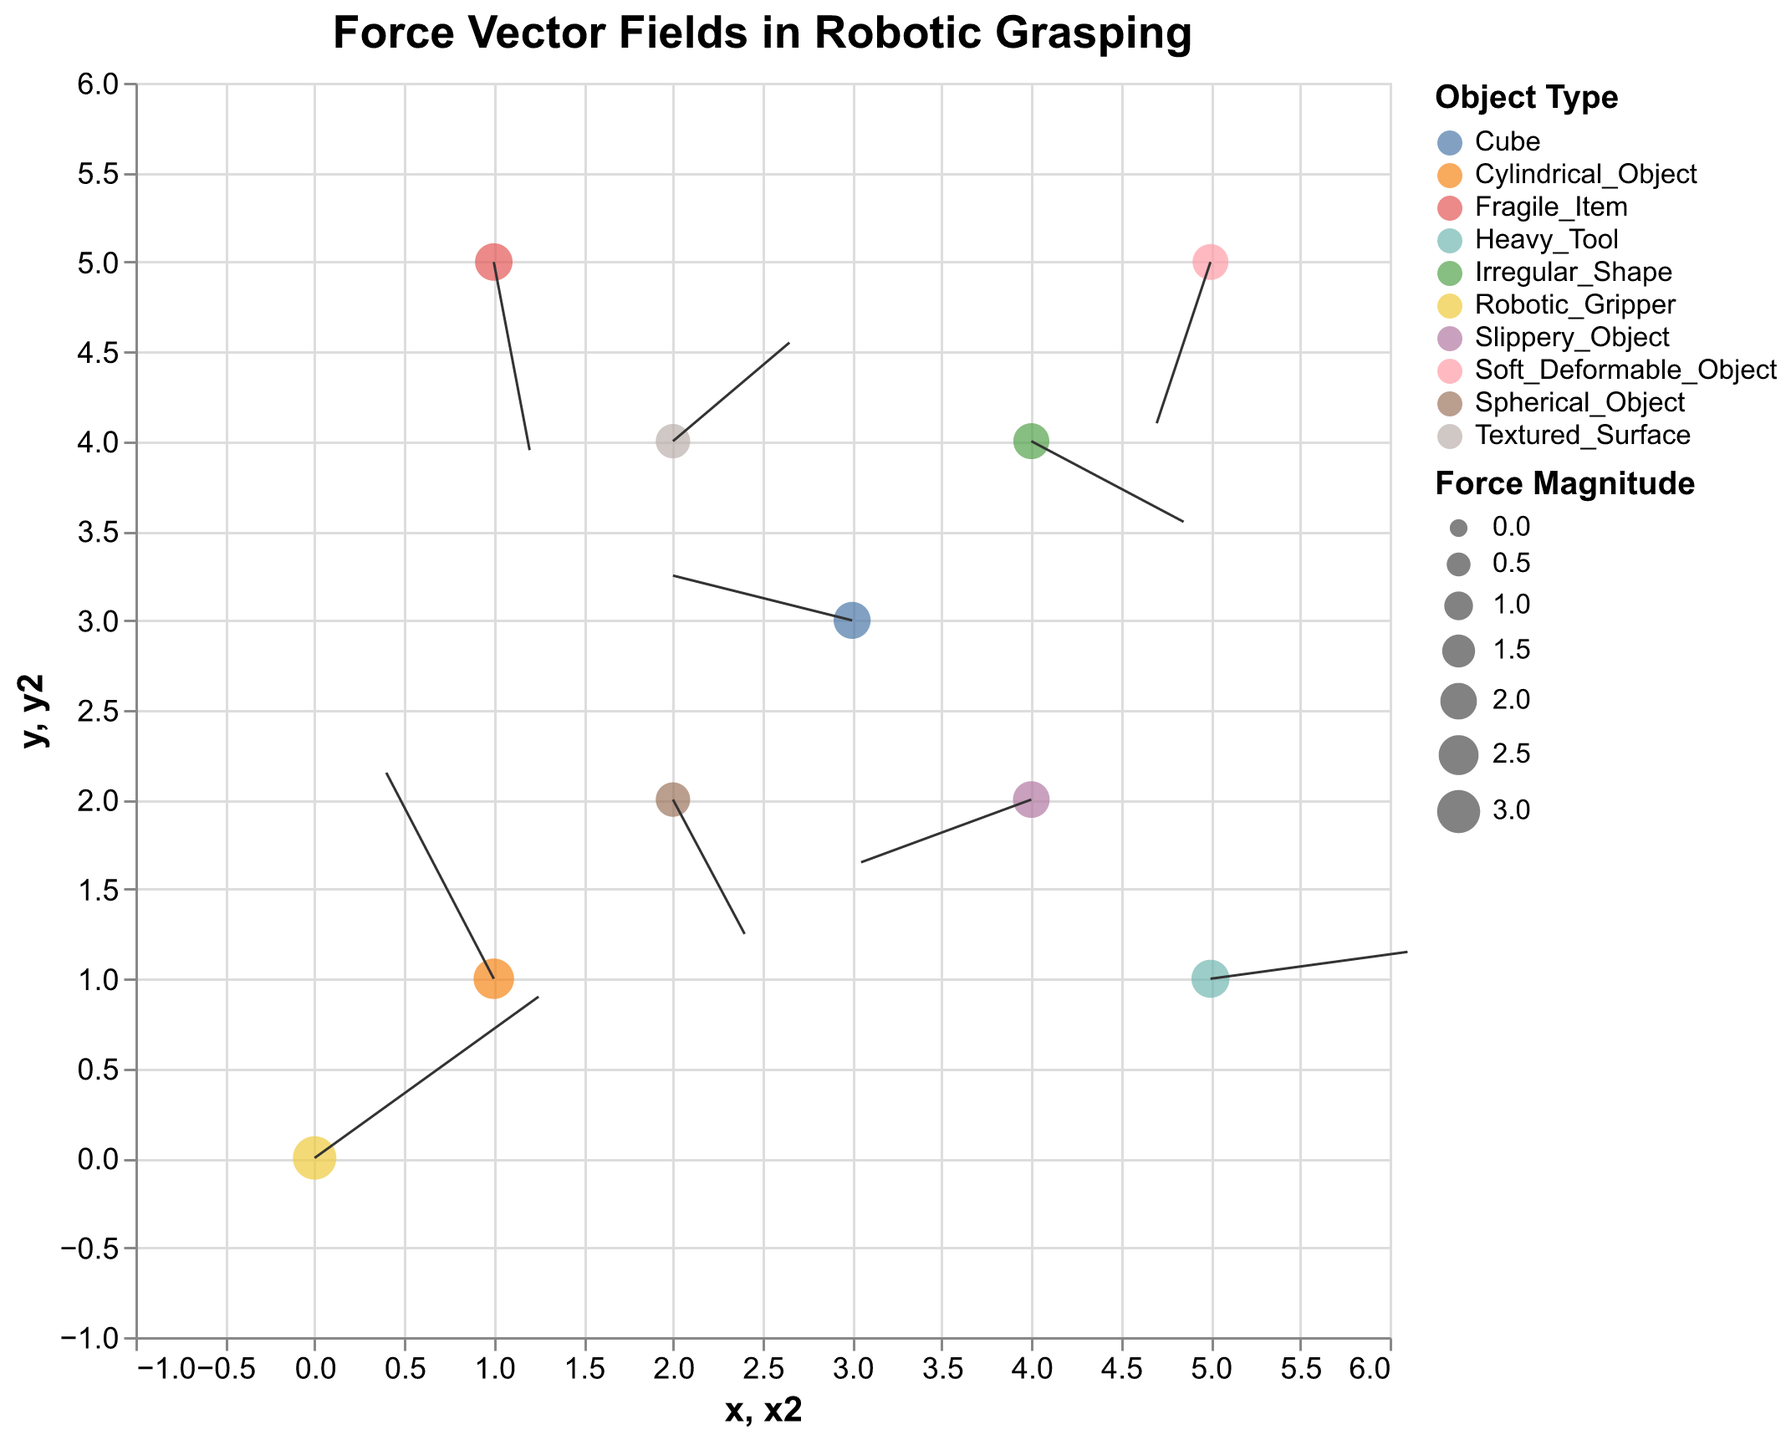What's the title of the figure? The title is usually located at the top portion of the figure. By directly looking at the top, the title "Force Vector Fields in Robotic Grasping" can be identified.
Answer: Force Vector Fields in Robotic Grasping Which object in the data has the highest force magnitude? By referring to the size of the points in the plot, we see that "Robotic_Gripper" denotes the largest point size representing the highest magnitude of 3.07.
Answer: Robotic_Gripper How many different types of objects are depicted in the graph? Each type of object has its own distinct color in the legend. Counting these colors, we see there are ten different objects displayed.
Answer: 10 Which object type has a negative u component and a significant positive v component for its force vector? Inspecting the force vector directions, "Cylindrical_Object" has a negative u component (-1.2) and a positive v component (2.3).
Answer: Cylindrical_Object Compare the vectors of the "Robotic_Gripper" and "Heavy_Tool". Which one has a larger horizontal component (u)? By checking the u values, we see "Robotic_Gripper" has a u of 2.5, and "Heavy_Tool" has a u of 2.2. Hence, "Robotic_Gripper" has the larger horizontal component.
Answer: Robotic_Gripper What is the average force magnitude of all the objects? Summing up the magnitudes (3.07 + 2.59 + 1.70 + 2.06 + 1.92 + 1.90 + 1.70 + 2.02 + 2.14 + 2.22) gives 21.32. Dividing by the number of objects (10) gives the average magnitude of 2.132.
Answer: 2.132 Which object has a force vector pointing in the fourth quadrant of the XY plane? Analyzing the direction of vectors, "Soft_Deformable_Object" has its u and v values both negative (-0.6, -1.8), indicating a vector in the fourth quadrant.
Answer: Soft_Deformable_Object Among "Textured_Surface" and "Slippery_Object", which has a higher force magnitude? Comparing the magnitudes, "Slippery_Object" has 2.02, while "Textured_Surface" has 1.70. Hence, "Slippery_Object" has a higher magnitude.
Answer: Slippery_Object For the "Fragile_Item", what is the resultant vector's angle with the horizontal axis? The vector (u, v) is (0.4, -2.1). Calculating the angle: θ = arctan(v/u) ≈ arctan(-2.1/0.4) = arctan(-5.25) ≈ -79°.
Answer: -79° What pattern do you observe between the force magnitudes and the types of objects? By examining, we notice objects like "Robotic_Gripper" and "Heavy_Tool" (potentially rigid, solid items) have higher magnitudes, while "Soft_Deformable_Object" and "Textured_Surface" (potentially soft, textured objects) have smaller magnitudes.
Answer: Rigid/solid objects have higher magnitudes, while soft/textured ones have lower magnitudes 